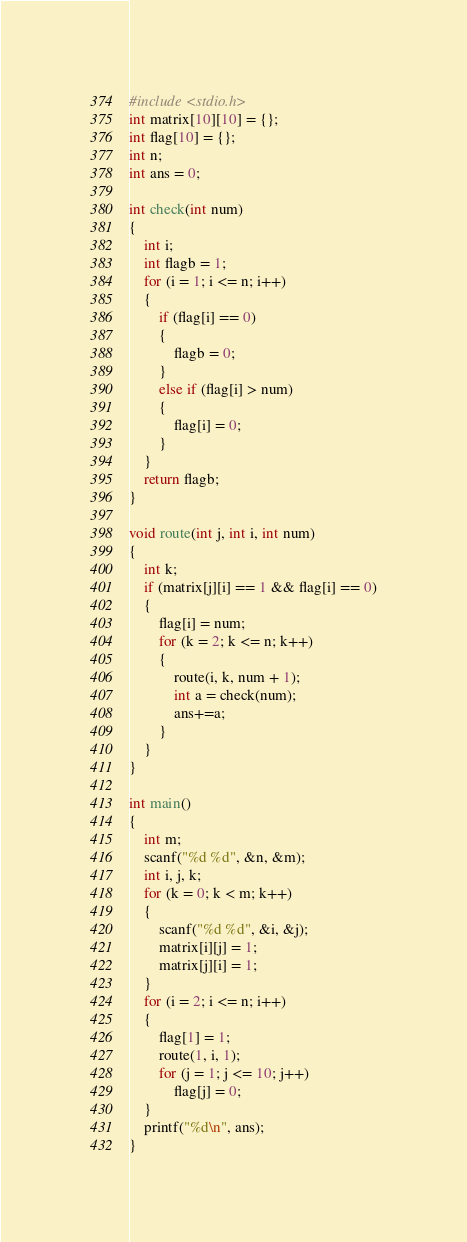Convert code to text. <code><loc_0><loc_0><loc_500><loc_500><_C_>
#include <stdio.h>
int matrix[10][10] = {};
int flag[10] = {};
int n;
int ans = 0;

int check(int num)
{
    int i;
    int flagb = 1;
    for (i = 1; i <= n; i++)
    {
        if (flag[i] == 0)
        {
            flagb = 0;
        }
        else if (flag[i] > num)
        {
            flag[i] = 0;
        }
    }
    return flagb;
}

void route(int j, int i, int num)
{
    int k;
    if (matrix[j][i] == 1 && flag[i] == 0)
    {
        flag[i] = num;
        for (k = 2; k <= n; k++)
        {
            route(i, k, num + 1);
            int a = check(num);
            ans+=a;
        }
    }
}

int main()
{
    int m;
    scanf("%d %d", &n, &m);
    int i, j, k;
    for (k = 0; k < m; k++)
    {
        scanf("%d %d", &i, &j);
        matrix[i][j] = 1;
        matrix[j][i] = 1;
    }
    for (i = 2; i <= n; i++)
    {
        flag[1] = 1;
        route(1, i, 1);
        for (j = 1; j <= 10; j++)
            flag[j] = 0;
    }
    printf("%d\n", ans);
}</code> 